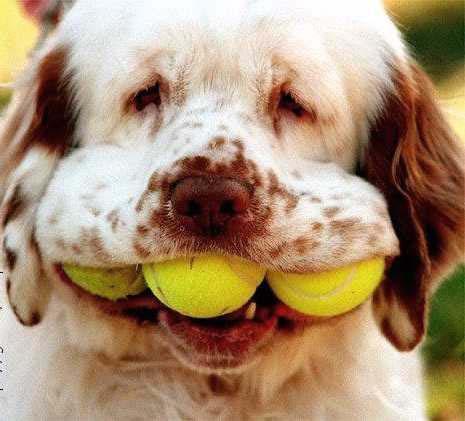How many dogs are in the picture?
Give a very brief answer. 1. How many balls does this dog have in its mouth?
Give a very brief answer. 3. How many teeth can you see?
Give a very brief answer. 1. How many sports balls can you see?
Give a very brief answer. 3. 